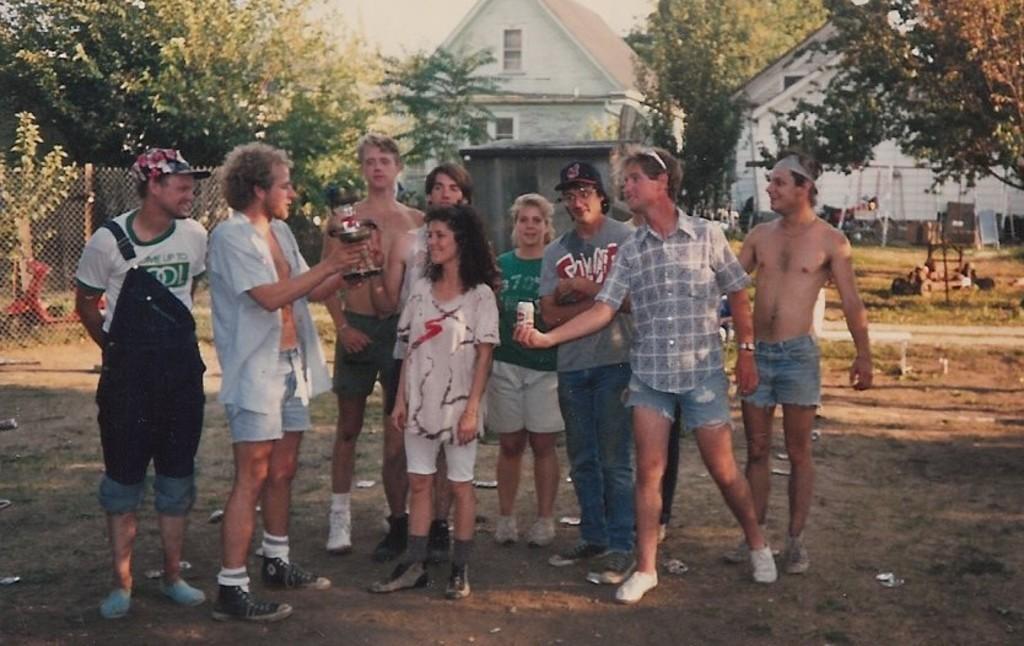Describe this image in one or two sentences. In this image I can see in the middle a group of people are standing, on the left side there is a vehicle and an iron net. In the background there are trees and houses. 